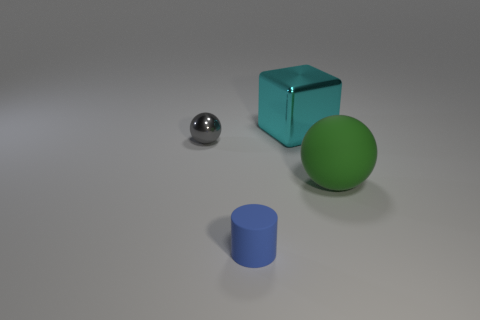Add 1 big red things. How many objects exist? 5 Subtract 1 cubes. How many cubes are left? 0 Add 2 cyan shiny things. How many cyan shiny things are left? 3 Add 2 tiny yellow matte cylinders. How many tiny yellow matte cylinders exist? 2 Subtract all gray spheres. How many spheres are left? 1 Subtract 1 green balls. How many objects are left? 3 Subtract all cylinders. How many objects are left? 3 Subtract all brown balls. Subtract all blue cylinders. How many balls are left? 2 Subtract all purple cylinders. How many yellow cubes are left? 0 Subtract all small cyan metallic cylinders. Subtract all tiny gray balls. How many objects are left? 3 